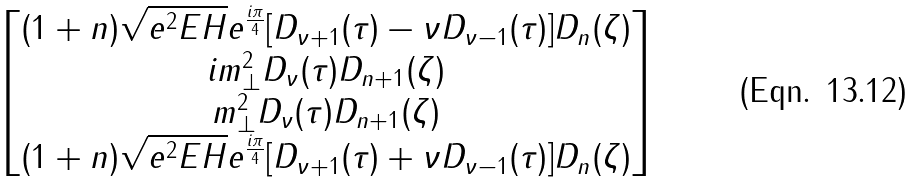<formula> <loc_0><loc_0><loc_500><loc_500>\begin{bmatrix} ( 1 + n ) \sqrt { e ^ { 2 } E H } e ^ { \frac { i \pi } 4 } [ D _ { \nu + 1 } ( \tau ) - \nu D _ { \nu - 1 } ( \tau ) ] D _ { n } ( \zeta ) \\ i m _ { \perp } ^ { 2 } D _ { \nu } ( \tau ) D _ { n + 1 } ( \zeta ) \\ m _ { \perp } ^ { 2 } D _ { \nu } ( \tau ) D _ { n + 1 } ( \zeta ) \\ ( 1 + n ) \sqrt { e ^ { 2 } E H } e ^ { \frac { i \pi } 4 } [ D _ { \nu + 1 } ( \tau ) + \nu D _ { \nu - 1 } ( \tau ) ] D _ { n } ( \zeta ) \end{bmatrix}</formula> 